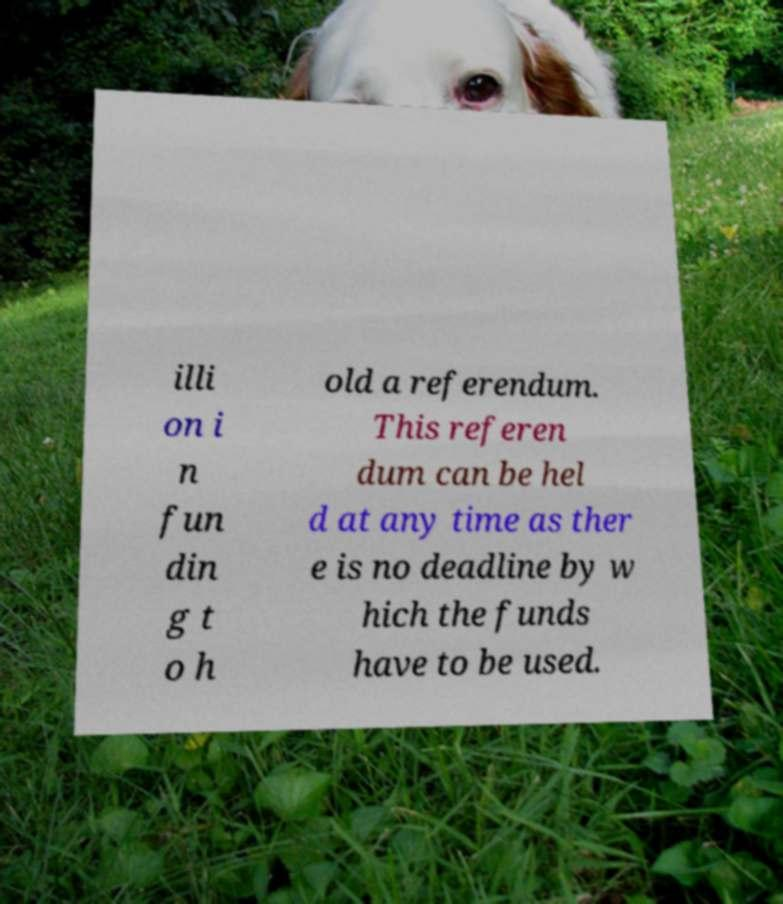Can you accurately transcribe the text from the provided image for me? illi on i n fun din g t o h old a referendum. This referen dum can be hel d at any time as ther e is no deadline by w hich the funds have to be used. 